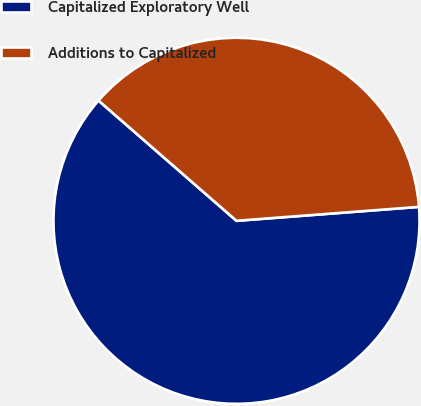Convert chart to OTSL. <chart><loc_0><loc_0><loc_500><loc_500><pie_chart><fcel>Capitalized Exploratory Well<fcel>Additions to Capitalized<nl><fcel>62.62%<fcel>37.38%<nl></chart> 